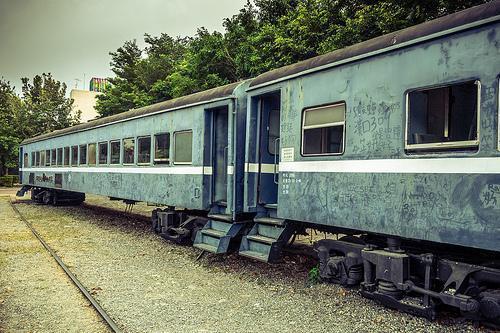How many cars are there?
Give a very brief answer. 2. How many trains are there?
Give a very brief answer. 1. 